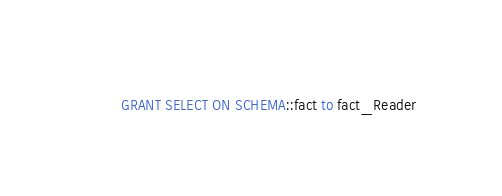Convert code to text. <code><loc_0><loc_0><loc_500><loc_500><_SQL_>GRANT SELECT ON SCHEMA::fact to fact_Reader</code> 